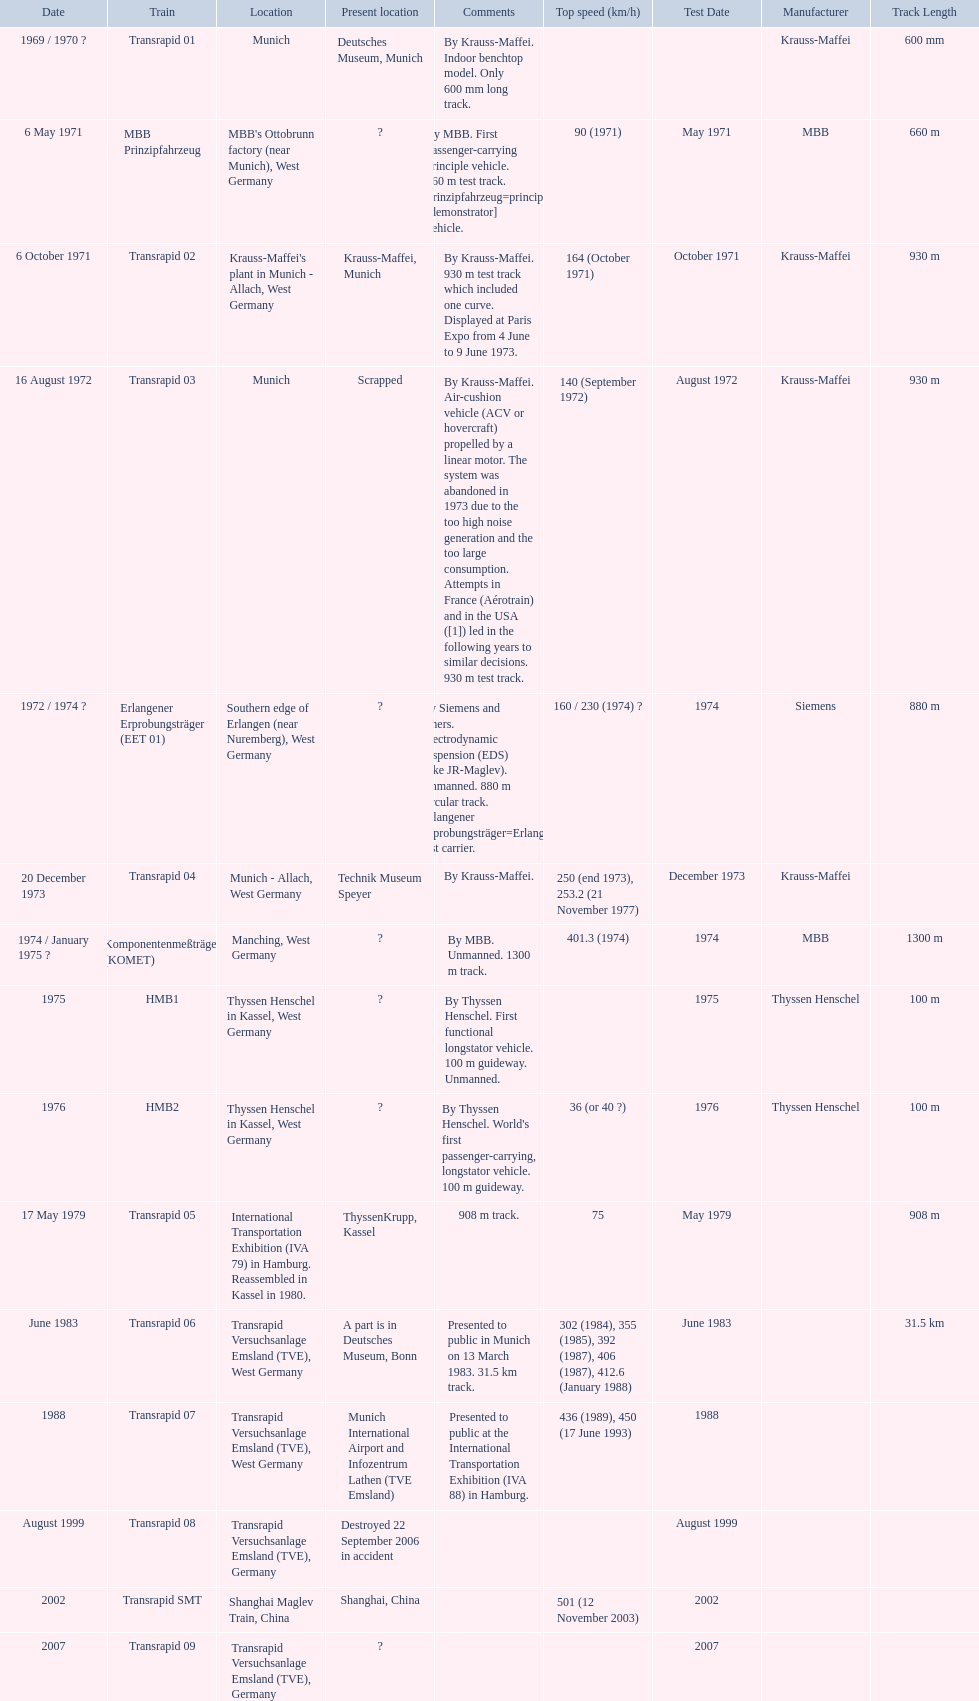What are all of the transrapid trains? Transrapid 01, Transrapid 02, Transrapid 03, Transrapid 04, Transrapid 05, Transrapid 06, Transrapid 07, Transrapid 08, Transrapid SMT, Transrapid 09. Of those, which train had to be scrapped? Transrapid 03. 